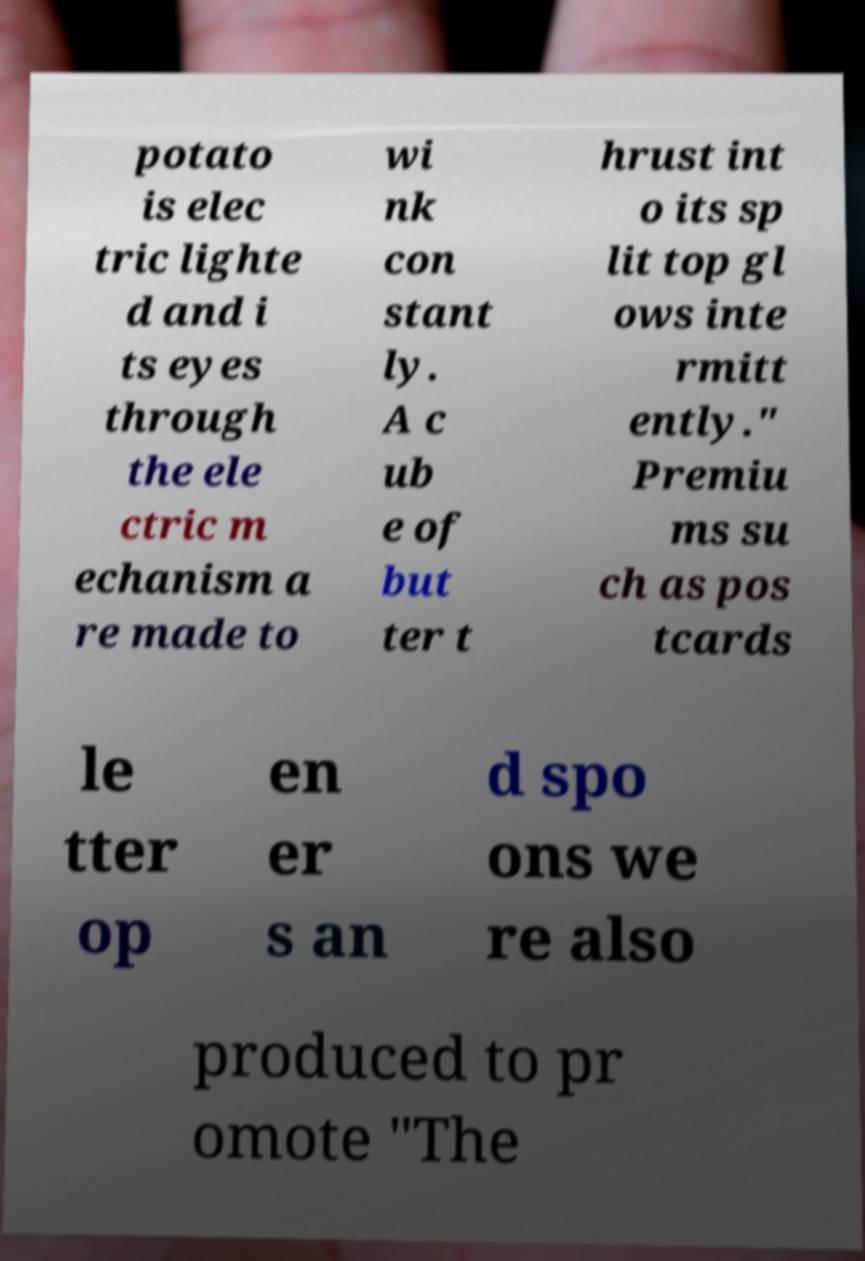What messages or text are displayed in this image? I need them in a readable, typed format. potato is elec tric lighte d and i ts eyes through the ele ctric m echanism a re made to wi nk con stant ly. A c ub e of but ter t hrust int o its sp lit top gl ows inte rmitt ently." Premiu ms su ch as pos tcards le tter op en er s an d spo ons we re also produced to pr omote "The 